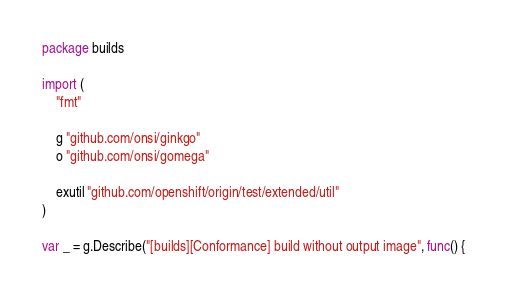<code> <loc_0><loc_0><loc_500><loc_500><_Go_>package builds

import (
	"fmt"

	g "github.com/onsi/ginkgo"
	o "github.com/onsi/gomega"

	exutil "github.com/openshift/origin/test/extended/util"
)

var _ = g.Describe("[builds][Conformance] build without output image", func() {</code> 